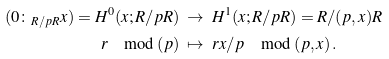Convert formula to latex. <formula><loc_0><loc_0><loc_500><loc_500>( 0 \colon _ { R / p R } x ) = H ^ { 0 } ( x ; R / p R ) & \ \to \ H ^ { 1 } ( x ; R / p R ) = R / ( p , x ) R \\ r \mod ( p ) & \ \mapsto \ r x / p \mod ( p , x ) \, .</formula> 